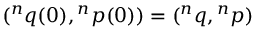<formula> <loc_0><loc_0><loc_500><loc_500>^ { n } q ( 0 ) ^ { n } p ( 0 ) ) = ^ { n } q ^ { n } p )</formula> 